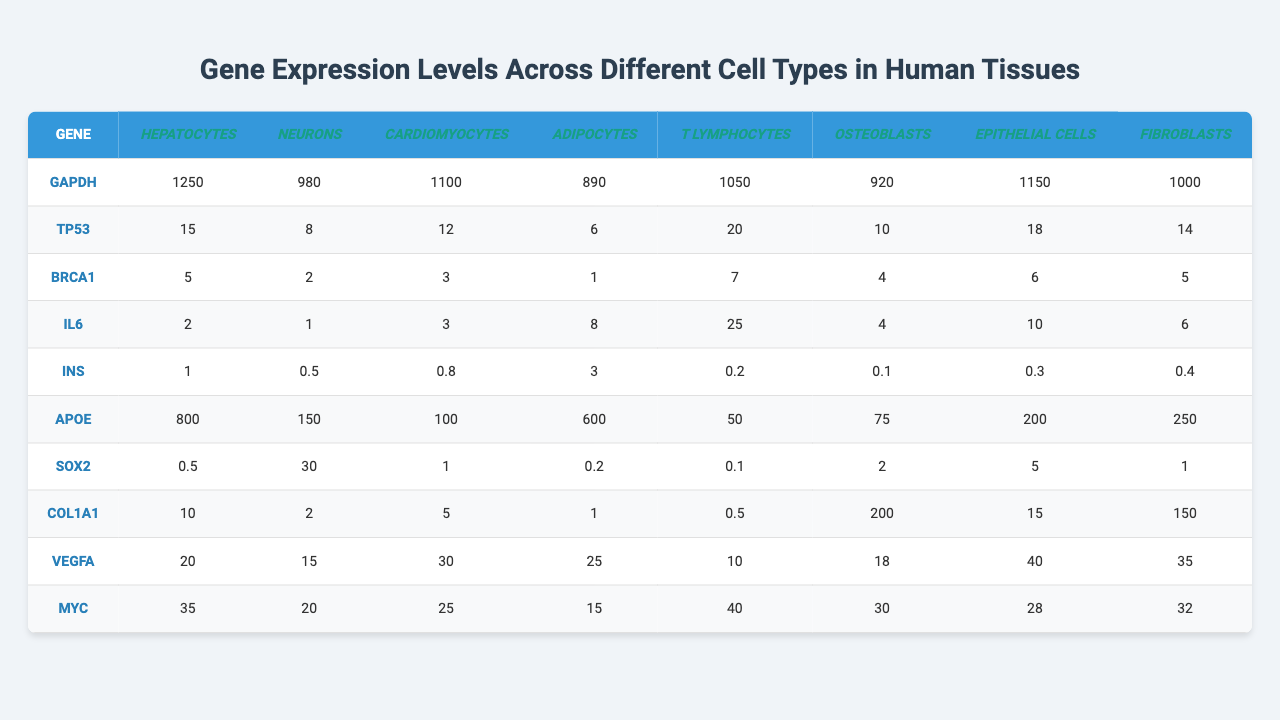What is the gene expression level of GAPDH in Neurons? From the table, the expression level of GAPDH in Neurons is directly listed as 980 FPKM.
Answer: 980 FPKM Which cell type has the highest expression level of IL6? The table shows the expression levels of IL6 across different cell types, and the highest value is 25 FPKM, associated with T Lymphocytes.
Answer: T Lymphocytes What is the average expression level of TP53 across all cell types? To find the average, we sum all expression levels of TP53: 15 + 8 + 12 + 6 + 20 + 10 + 18 + 14 = 93. There are 8 cell types, so the average is 93 / 8 = 11.625.
Answer: 11.625 FPKM Do Epithelial Cells express more COL1A1 than Adipocytes? The expression level of COL1A1 in Epithelial Cells is 15 FPKM, while in Adipocytes it is 1 FPKM. Since 15 > 1, the statement is true.
Answer: Yes What is the total expression level of APOE in all cell types? We sum the expression levels of APOE: 800 + 150 + 100 + 600 + 50 + 75 + 200 + 250 = 2225 FPKM.
Answer: 2225 FPKM Which gene has the highest expression level in Cardiomyocytes? Looking at Cardiomyocytes, we see the expression levels of all genes. The highest value is the expression level of VEGFA at 30 FPKM.
Answer: VEGFA How does MYC expression in Fibroblasts compare to T Lymphocytes? MYC expression in Fibroblasts is 28 FPKM and in T Lymphocytes it is 40 FPKM. Since 28 < 40, MYC is lower in Fibroblasts compared to T Lymphocytes.
Answer: Lower What is the median gene expression level of INS across all cell types? The values for INS are [1, 0.5, 0.8, 3, 0.2, 0.1, 0.3, 0.4]. Sorting these gives us [0.1, 0.2, 0.3, 0.4, 0.5, 0.8, 1, 3]. The median is the average of the 4th and 5th values: (0.4 + 0.5) / 2 = 0.45.
Answer: 0.45 FPKM Which cell type has the greatest average size in micrometers? Consulting the average cell sizes listed, Cardiomyocytes and Adipocytes both have a size of 100 μm, which is the highest compared to others.
Answer: Cardiomyocytes and Adipocytes What is the difference in mitochondrial content between Neurons and T Lymphocytes? The mitochondrial content for Neurons is 2000 and for T Lymphocytes it is 50. The difference is 2000 - 50 = 1950.
Answer: 1950 Which gene has the lowest expression level in Adipocytes? The gene expression levels in Adipocytes are: GAPDH (890), TP53 (6), BRCA1 (1), IL6 (8), INS (3), APOE (600), SOX2 (0.2), COL1A1 (1), VEGFA (25), MYC (15). The lowest is BRCA1 at 1 FPKM.
Answer: BRCA1 